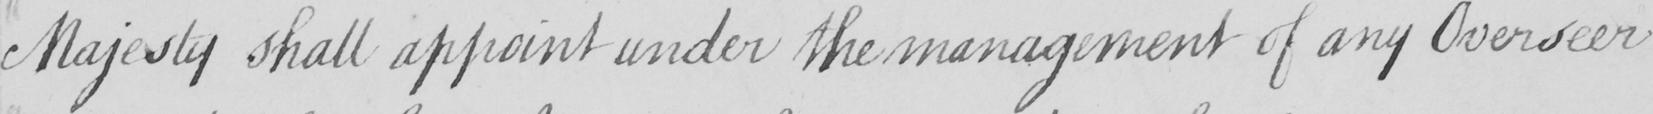Can you read and transcribe this handwriting? Majesty shall appoint under the management of any Overseer 